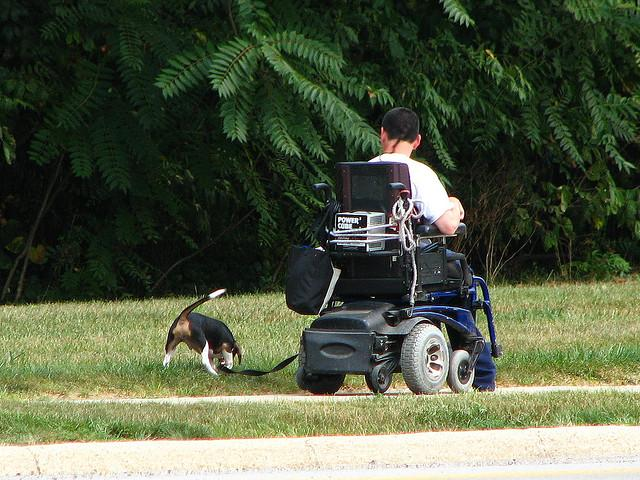What is the purpose of the power cube on the back of the wheelchair?

Choices:
A) storage
B) for aesthetics
C) for weight
D) move it move it 